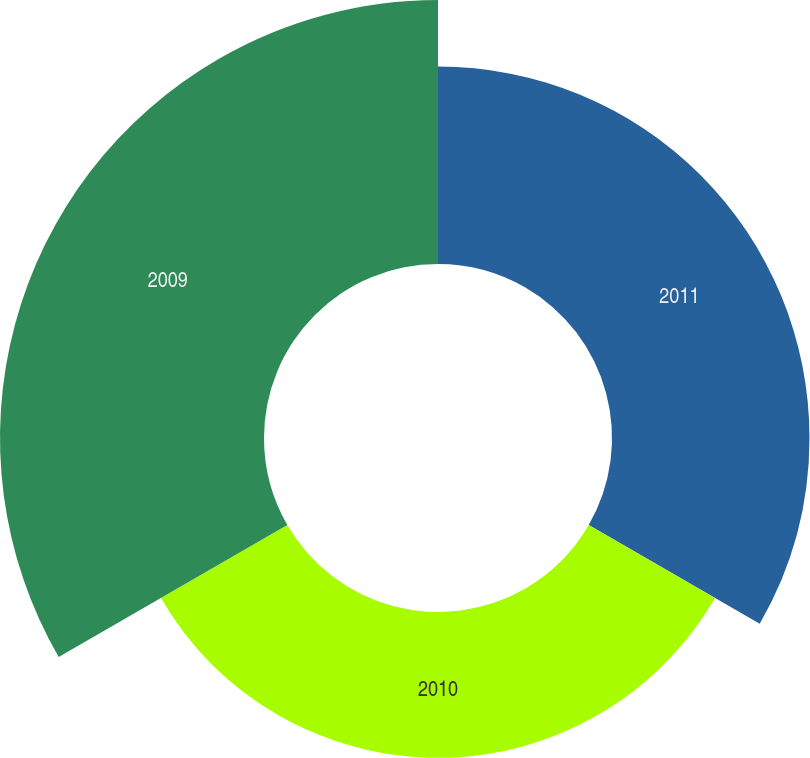Convert chart. <chart><loc_0><loc_0><loc_500><loc_500><pie_chart><fcel>2011<fcel>2010<fcel>2009<nl><fcel>32.52%<fcel>24.01%<fcel>43.47%<nl></chart> 